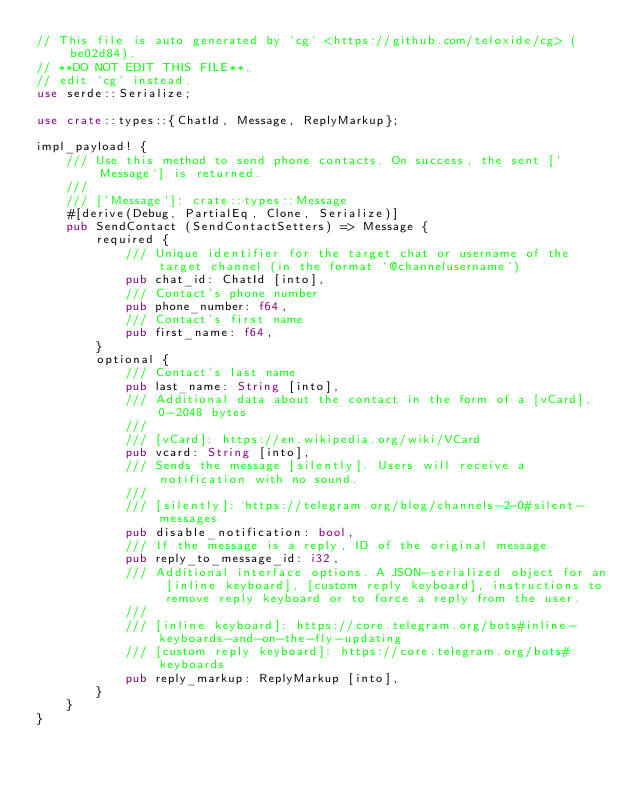Convert code to text. <code><loc_0><loc_0><loc_500><loc_500><_Rust_>// This file is auto generated by `cg` <https://github.com/teloxide/cg> (be02d84).
// **DO NOT EDIT THIS FILE**,
// edit `cg` instead.
use serde::Serialize;

use crate::types::{ChatId, Message, ReplyMarkup};

impl_payload! {
    /// Use this method to send phone contacts. On success, the sent [`Message`] is returned.
    ///
    /// [`Message`]: crate::types::Message
    #[derive(Debug, PartialEq, Clone, Serialize)]
    pub SendContact (SendContactSetters) => Message {
        required {
            /// Unique identifier for the target chat or username of the target channel (in the format `@channelusername`)
            pub chat_id: ChatId [into],
            /// Contact's phone number
            pub phone_number: f64,
            /// Contact's first name
            pub first_name: f64,
        }
        optional {
            /// Contact's last name
            pub last_name: String [into],
            /// Additional data about the contact in the form of a [vCard], 0-2048 bytes
            ///
            /// [vCard]: https://en.wikipedia.org/wiki/VCard
            pub vcard: String [into],
            /// Sends the message [silently]. Users will receive a notification with no sound.
            ///
            /// [silently]: https://telegram.org/blog/channels-2-0#silent-messages
            pub disable_notification: bool,
            /// If the message is a reply, ID of the original message
            pub reply_to_message_id: i32,
            /// Additional interface options. A JSON-serialized object for an [inline keyboard], [custom reply keyboard], instructions to remove reply keyboard or to force a reply from the user.
            ///
            /// [inline keyboard]: https://core.telegram.org/bots#inline-keyboards-and-on-the-fly-updating
            /// [custom reply keyboard]: https://core.telegram.org/bots#keyboards
            pub reply_markup: ReplyMarkup [into],
        }
    }
}
</code> 